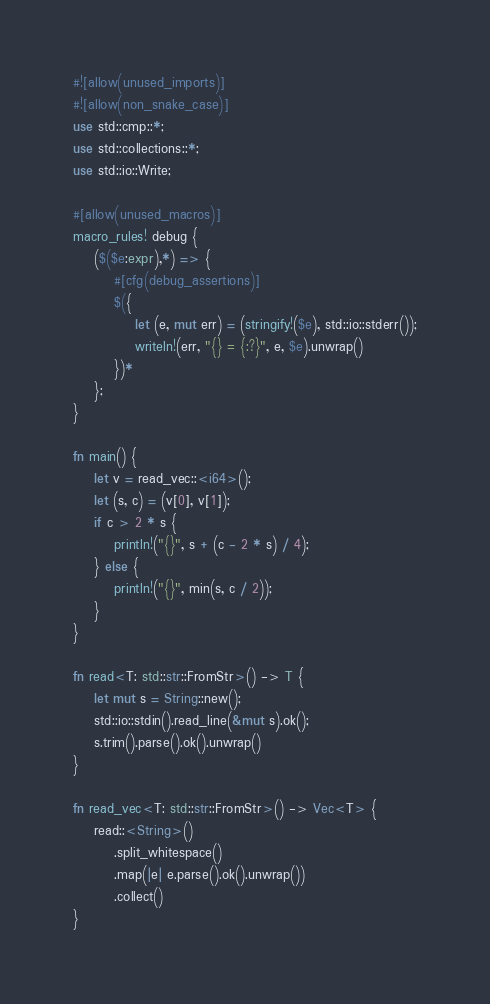<code> <loc_0><loc_0><loc_500><loc_500><_Rust_>#![allow(unused_imports)]
#![allow(non_snake_case)]
use std::cmp::*;
use std::collections::*;
use std::io::Write;

#[allow(unused_macros)]
macro_rules! debug {
    ($($e:expr),*) => {
        #[cfg(debug_assertions)]
        $({
            let (e, mut err) = (stringify!($e), std::io::stderr());
            writeln!(err, "{} = {:?}", e, $e).unwrap()
        })*
    };
}

fn main() {
    let v = read_vec::<i64>();
    let (s, c) = (v[0], v[1]);
    if c > 2 * s {
        println!("{}", s + (c - 2 * s) / 4);
    } else {
        println!("{}", min(s, c / 2));
    }
}

fn read<T: std::str::FromStr>() -> T {
    let mut s = String::new();
    std::io::stdin().read_line(&mut s).ok();
    s.trim().parse().ok().unwrap()
}

fn read_vec<T: std::str::FromStr>() -> Vec<T> {
    read::<String>()
        .split_whitespace()
        .map(|e| e.parse().ok().unwrap())
        .collect()
}
</code> 